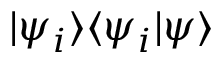Convert formula to latex. <formula><loc_0><loc_0><loc_500><loc_500>| \psi _ { i } \rangle \langle \psi _ { i } | \psi \rangle</formula> 